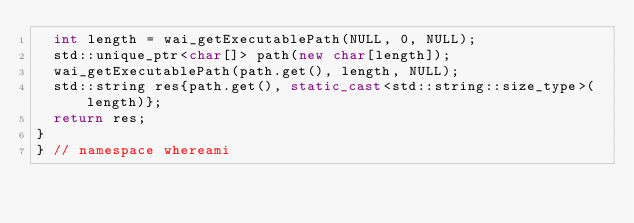<code> <loc_0><loc_0><loc_500><loc_500><_C++_>  int length = wai_getExecutablePath(NULL, 0, NULL);
  std::unique_ptr<char[]> path(new char[length]);
  wai_getExecutablePath(path.get(), length, NULL);
  std::string res{path.get(), static_cast<std::string::size_type>(length)};
  return res;
}
} // namespace whereami
</code> 